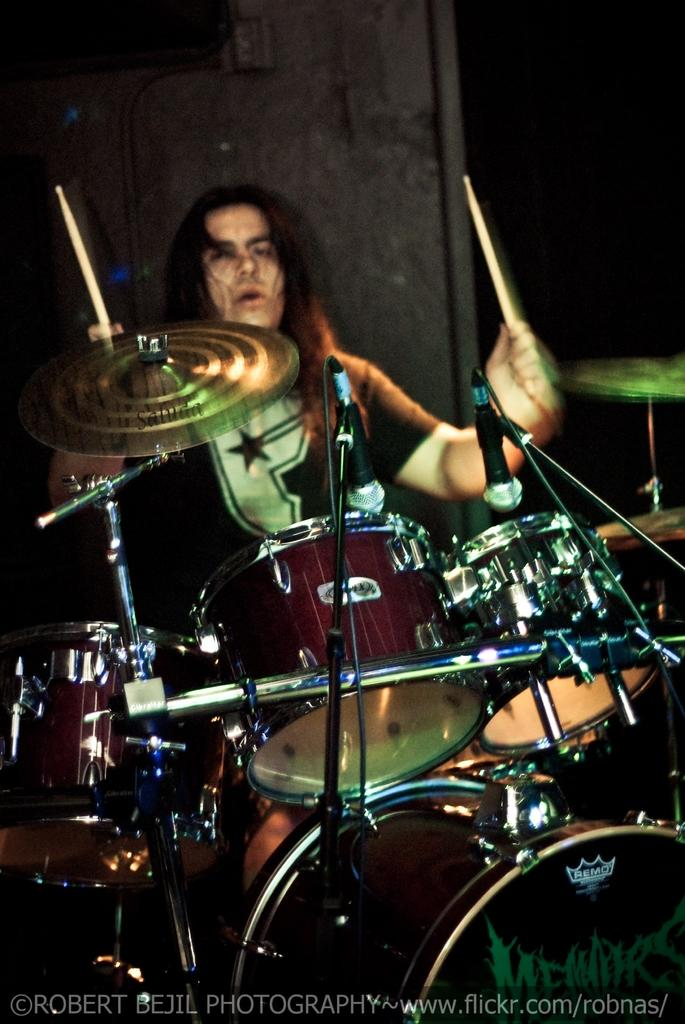What is the main activity being depicted in the image? There is a person in the image who is playing drums. Is there anyone else present in the image? Yes, there is another person in the image. What is the second person holding in his hands? The second person is holding sticks in his hands. What type of company is the person in the image working for? There is no information in the image about the person working for a company. How many groups are visible in the image? There is no reference to groups in the image; it features two individuals engaged in musical activities. 